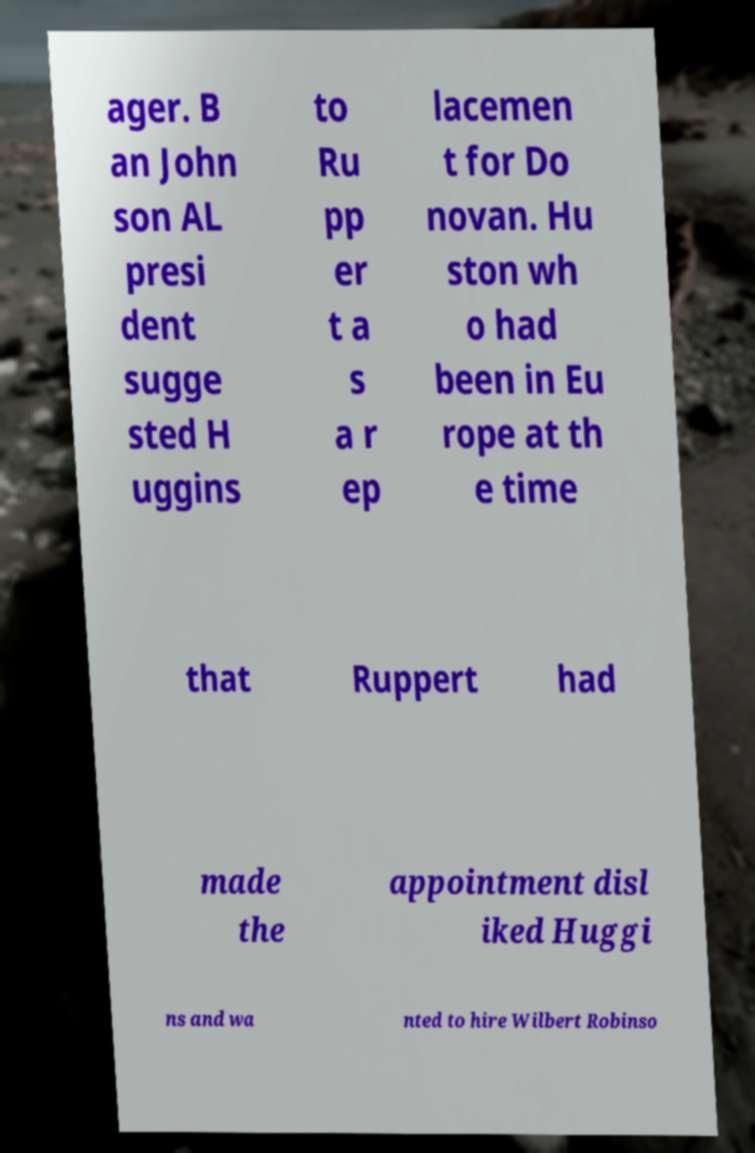For documentation purposes, I need the text within this image transcribed. Could you provide that? ager. B an John son AL presi dent sugge sted H uggins to Ru pp er t a s a r ep lacemen t for Do novan. Hu ston wh o had been in Eu rope at th e time that Ruppert had made the appointment disl iked Huggi ns and wa nted to hire Wilbert Robinso 